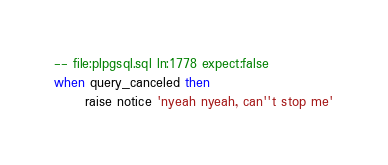<code> <loc_0><loc_0><loc_500><loc_500><_SQL_>-- file:plpgsql.sql ln:1778 expect:false
when query_canceled then
      raise notice 'nyeah nyeah, can''t stop me'
</code> 